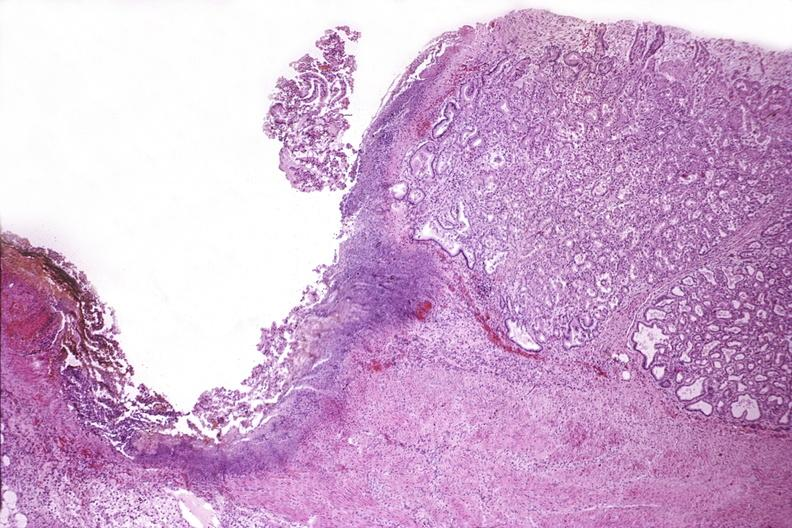what does this image show?
Answer the question using a single word or phrase. Duodenum 